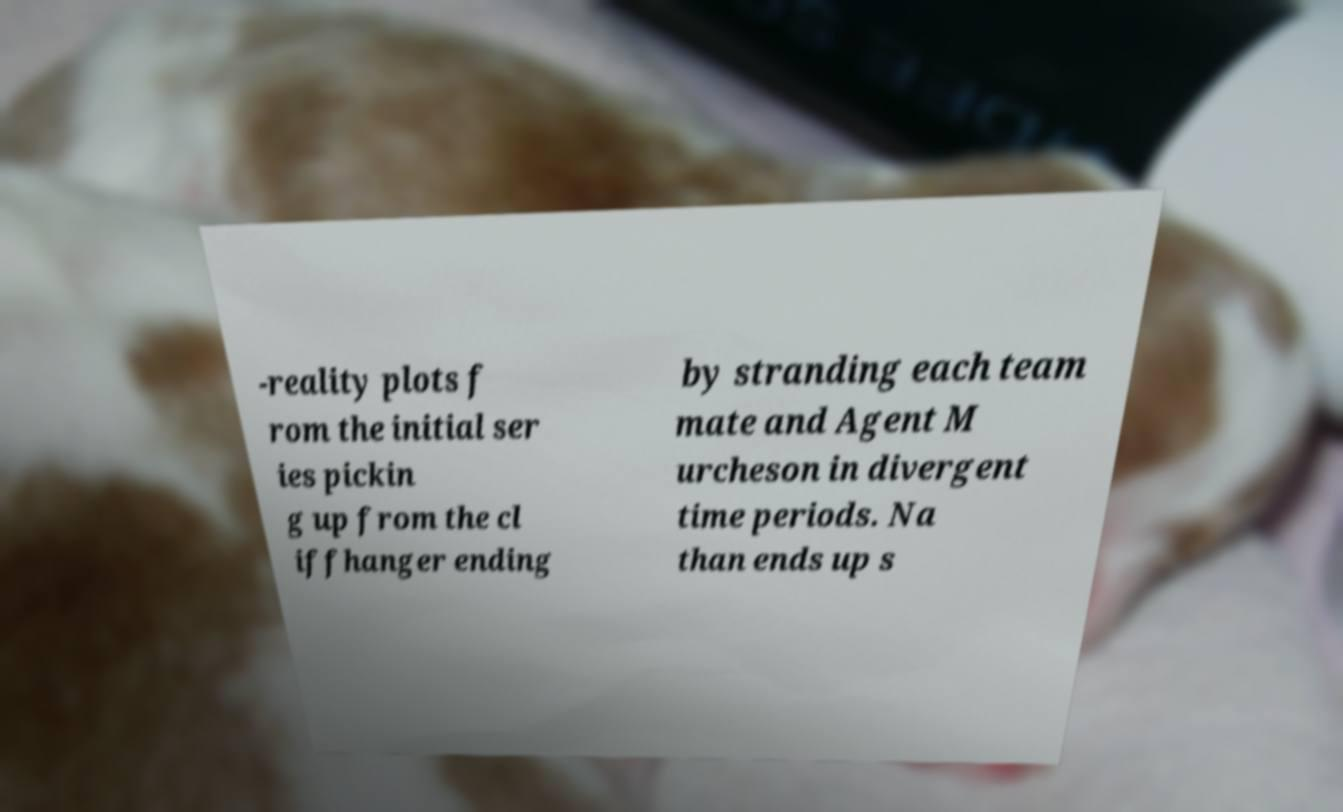Can you read and provide the text displayed in the image?This photo seems to have some interesting text. Can you extract and type it out for me? -reality plots f rom the initial ser ies pickin g up from the cl iffhanger ending by stranding each team mate and Agent M urcheson in divergent time periods. Na than ends up s 